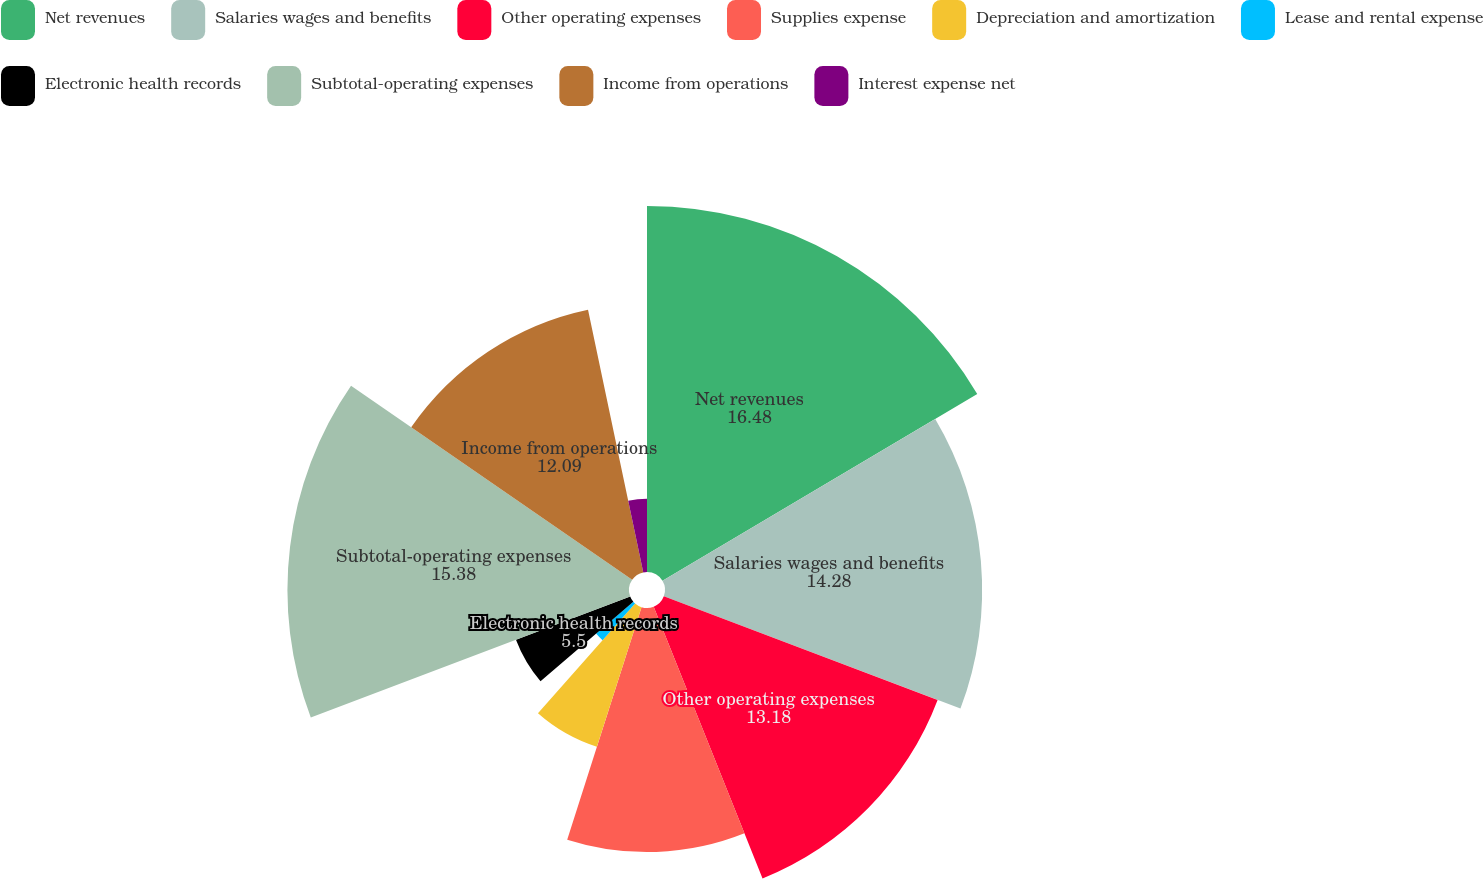Convert chart. <chart><loc_0><loc_0><loc_500><loc_500><pie_chart><fcel>Net revenues<fcel>Salaries wages and benefits<fcel>Other operating expenses<fcel>Supplies expense<fcel>Depreciation and amortization<fcel>Lease and rental expense<fcel>Electronic health records<fcel>Subtotal-operating expenses<fcel>Income from operations<fcel>Interest expense net<nl><fcel>16.48%<fcel>14.28%<fcel>13.18%<fcel>10.99%<fcel>6.6%<fcel>2.21%<fcel>5.5%<fcel>15.38%<fcel>12.09%<fcel>3.3%<nl></chart> 